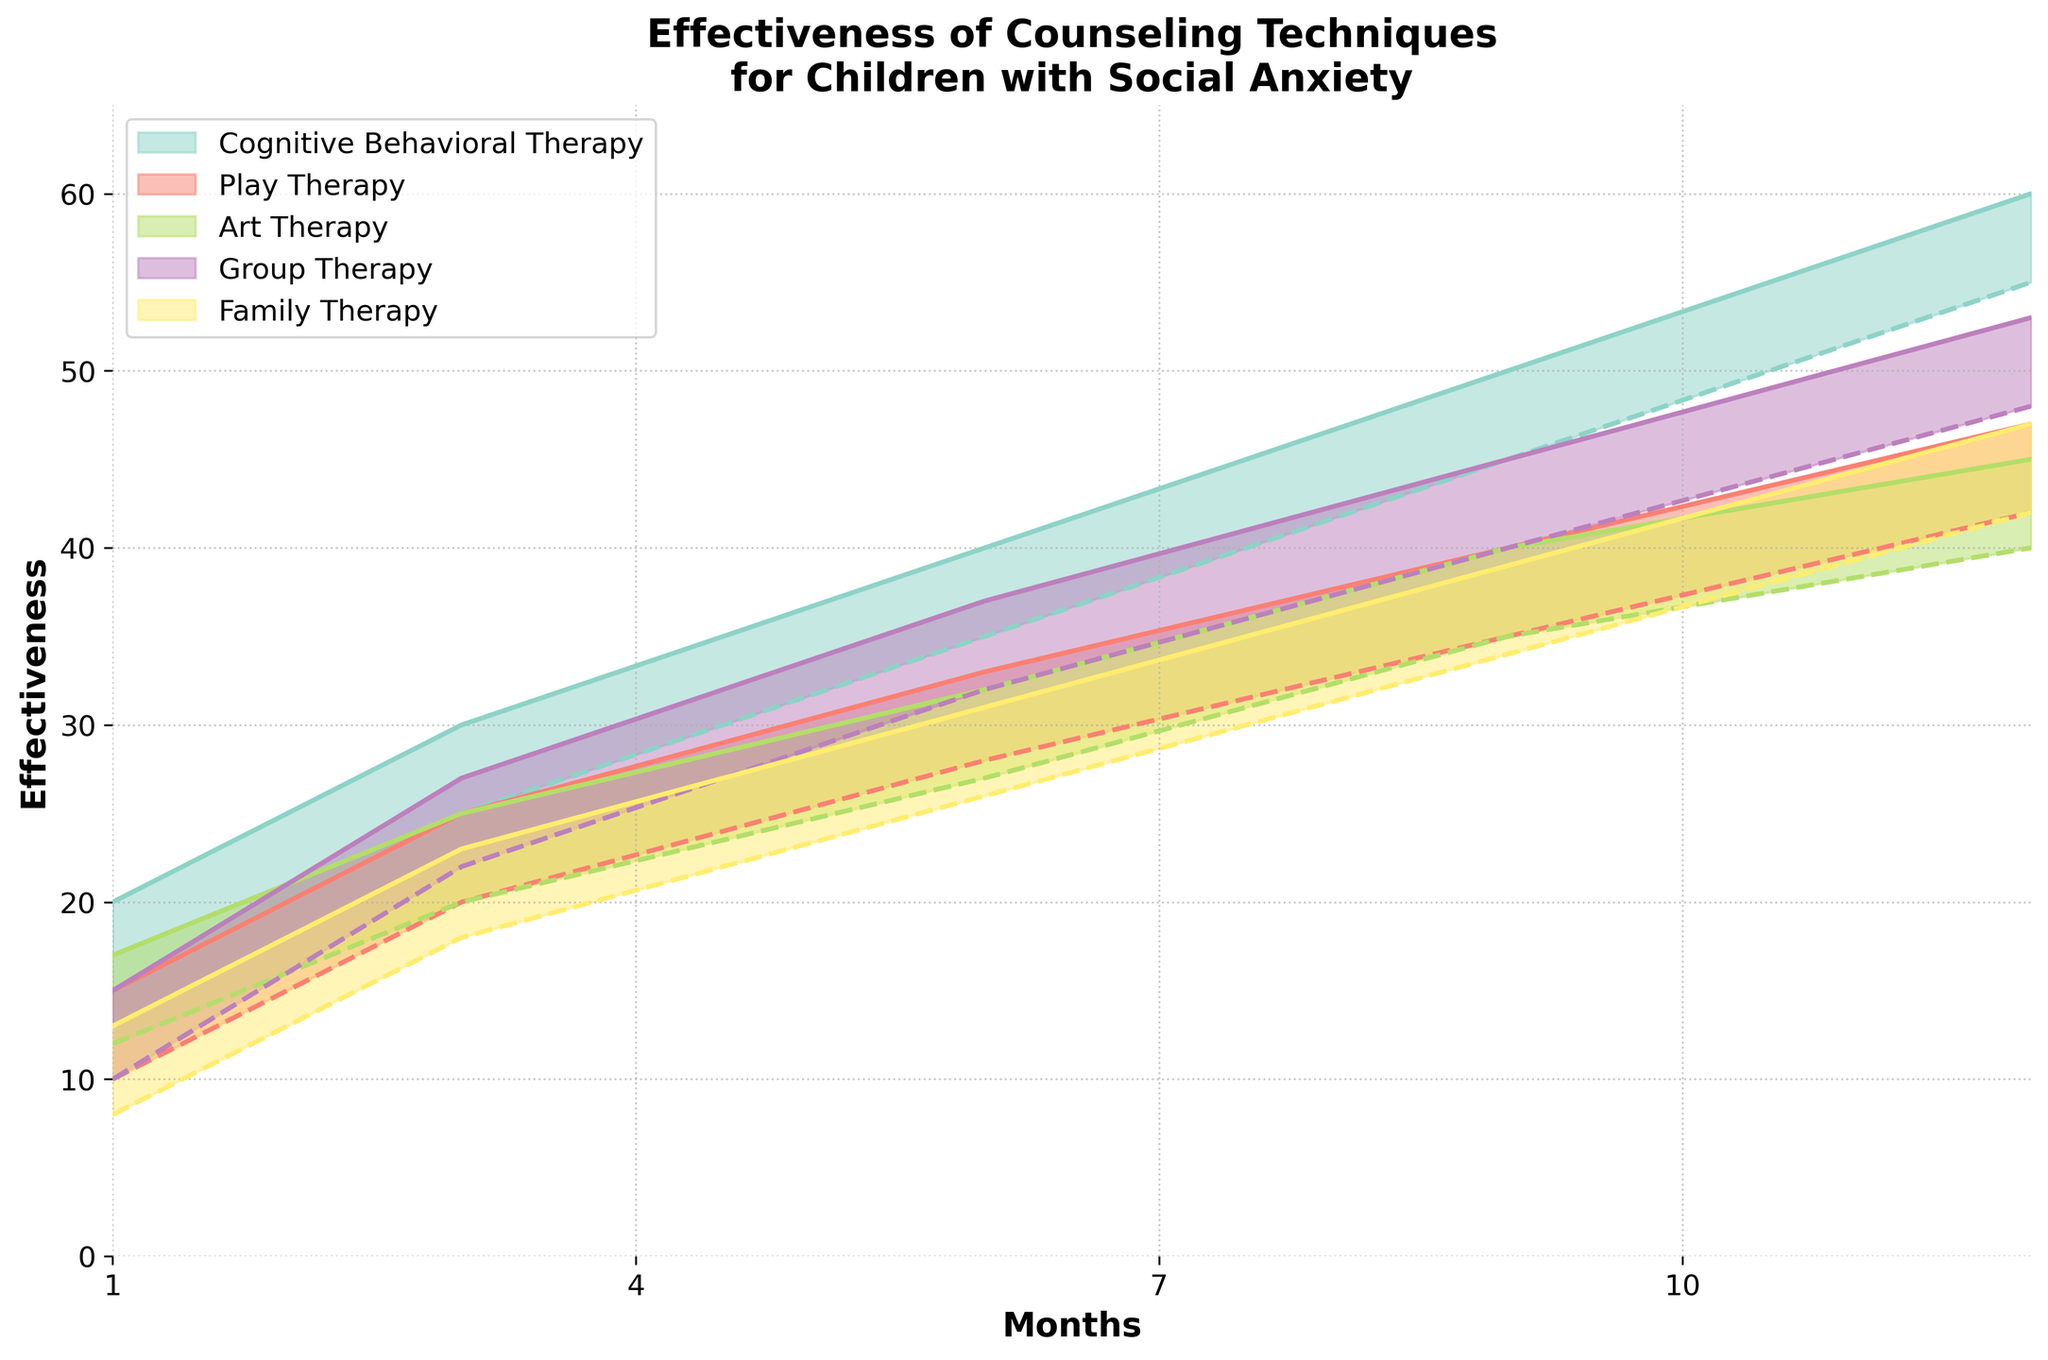What is the title of the figure? The title of the figure is usually found at the top and summarizes the content of the chart. In this case, it describes the effectiveness of counseling techniques for children with social anxiety over 12 months.
Answer: Effectiveness of Counseling Techniques for Children with Social Anxiety What do the x-axis and y-axis represent? The x-axis and y-axis labels should indicate what each axis represents in the figure. The x-axis shows the time in months, and the y-axis shows the effectiveness of the counseling techniques.
Answer: The x-axis represents months, and the y-axis represents effectiveness Which counseling technique has the highest effectiveness range at 12 months? To find the counseling technique with the highest effectiveness range at 12 months, you need to identify the highest maximum effectiveness at the 12-month mark. Cognitive Behavioral Therapy has the highest maximum effectiveness of 60, compared to the other techniques.
Answer: Cognitive Behavioral Therapy How does the effectiveness of Play Therapy change from month 1 to month 12? To understand how the effectiveness of Play Therapy changes over time, compare the values from month 1 (10-15) to month 12 (42-47). There is a noticeable increase in both the minimum and maximum effectiveness values over this period.
Answer: It increases from 10-15 to 42-47 Which technique shows the most consistent improvement over the 12 months? To determine which technique shows the most consistent improvement, examine the trends and smoothness of the changes across all months for each technique. Cognitive Behavioral Therapy appears to show the most consistent and steady improvement from months 1 to 12.
Answer: Cognitive Behavioral Therapy Compare the effectiveness ranges of Art Therapy and Family Therapy at 6 months. Which is higher? To compare the effectiveness ranges of Art Therapy and Family Therapy at 6 months, look at the effectiveness values for both techniques. Art Therapy ranges from 27-32, and Family Therapy ranges from 26-31. Art Therapy has a slightly higher range.
Answer: Art Therapy How does the effectiveness of Group Therapy at 9 months compare to its effectiveness at 3 months? To compare the effectiveness values, look at Group Therapy at 9 months (40-45) and 3 months (22-27). The values show an increase from the 3rd month to the 9th month.
Answer: It increases from 22-27 to 40-45 Which technique shows the least improvement in effectiveness over the 12-month period? To find the technique with the least improvement, compare the changes in the effectiveness ranges for each technique from month 1 to month 12. Family Therapy starts at 8-13 and ends at 42-47, showing a smaller relative increase compared to other techniques.
Answer: Family Therapy What is the overall trend in the effectiveness of Cognitive Behavioral Therapy over the 12 months? To identify the overall trend, observe the change in effectiveness values for Cognitive Behavioral Therapy at different points (1, 3, 6, 9, 12 months). The data shows a consistent and steady increase in both minimum and maximum effectiveness values.
Answer: Consistently increasing What is the average maximum effectiveness of all techniques at 12 months? To find the average maximum effectiveness at 12 months, sum the maximum effectiveness values for all techniques at 12 months and divide by the number of techniques: (60+47+45+53+47) / 5 = 252 / 5 = 50.4.
Answer: 50.4 